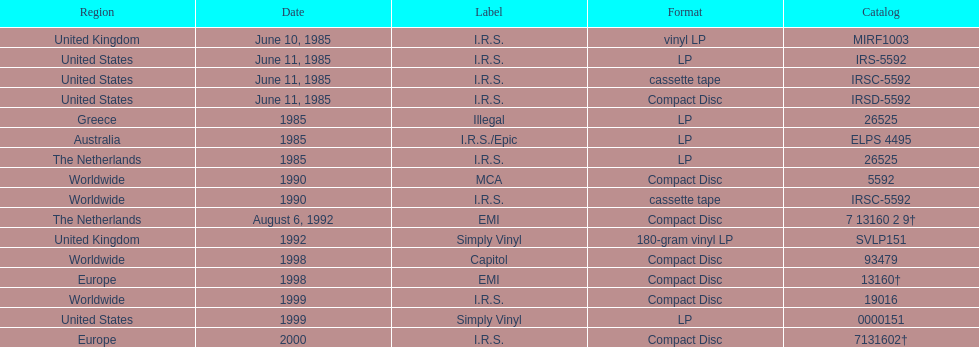What was the last region to experience the release? Europe. 